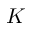Convert formula to latex. <formula><loc_0><loc_0><loc_500><loc_500>K</formula> 